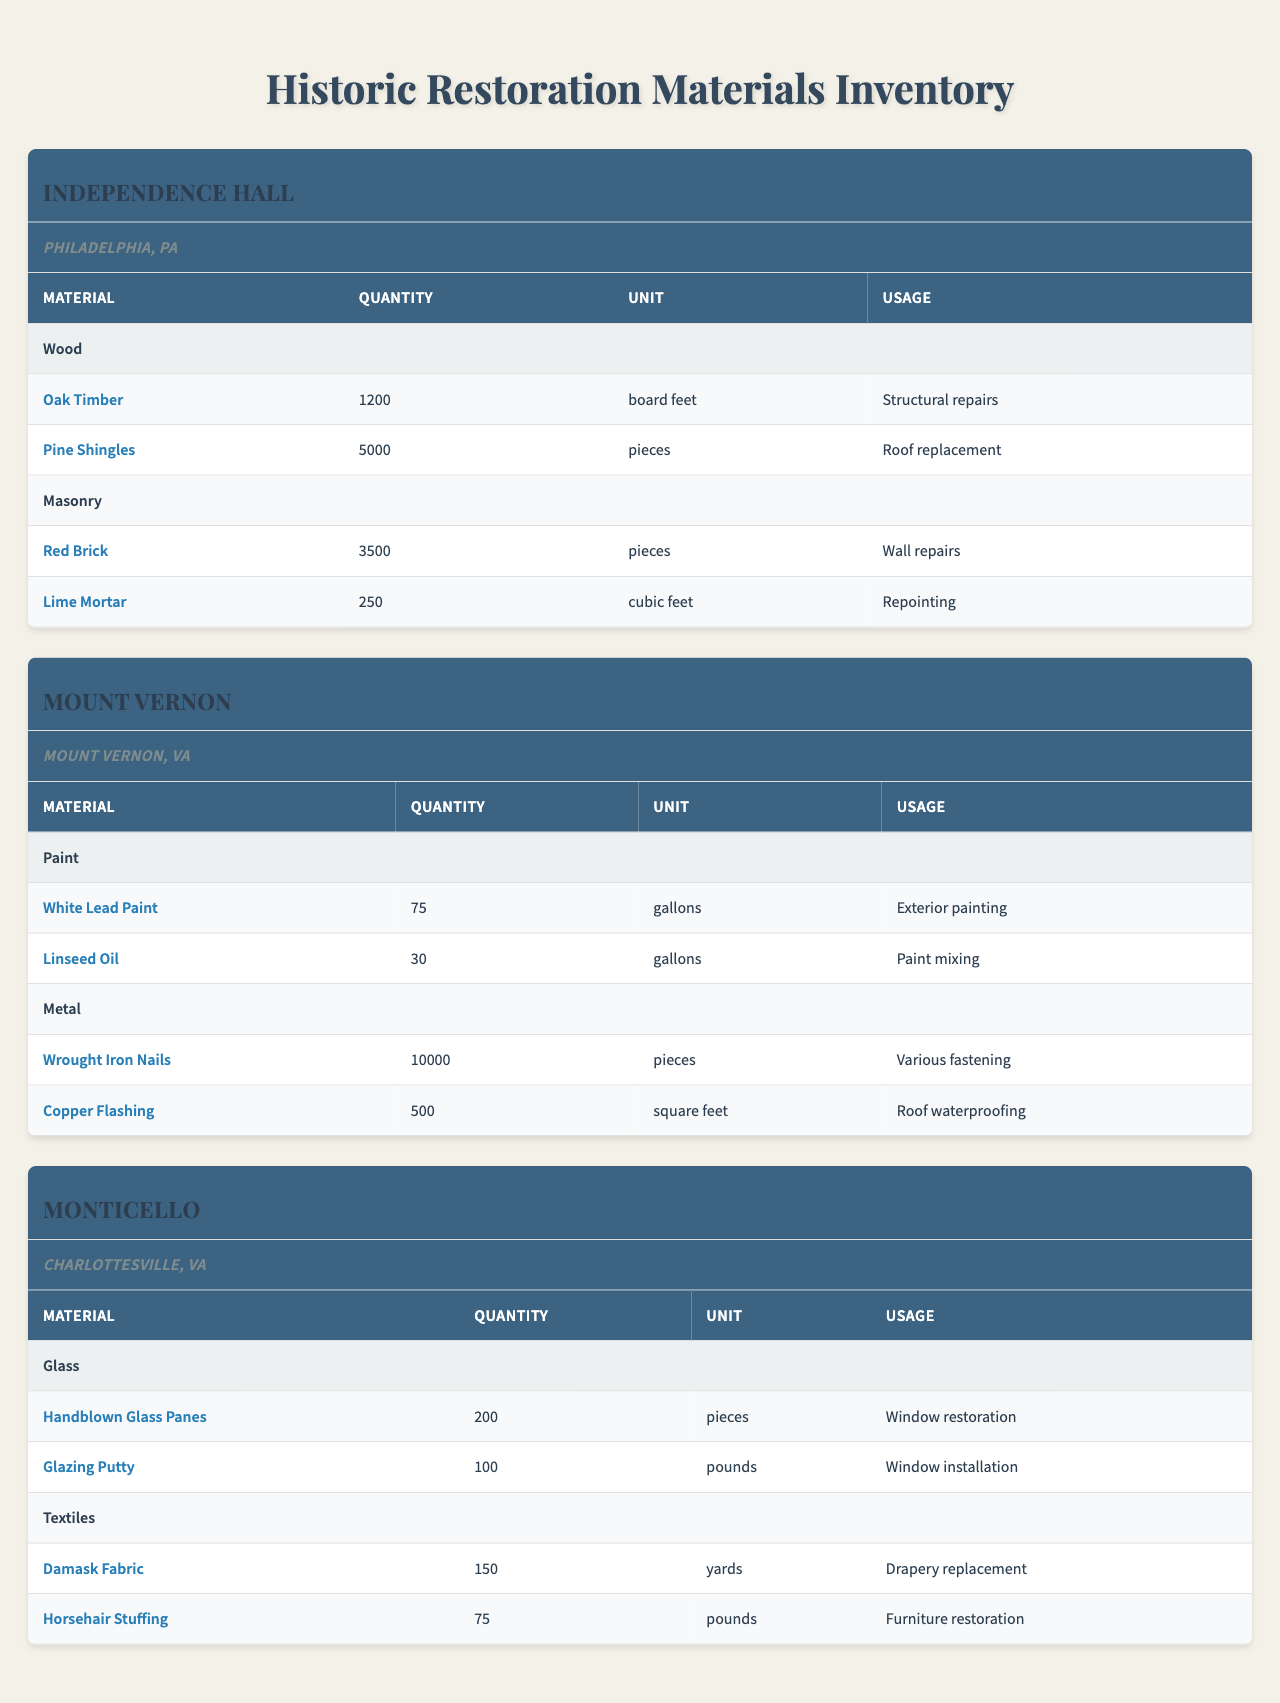What is the total quantity of Pine Shingles used at Independence Hall? The table shows that Pine Shingles have a quantity of 5000 pieces listed under Independence Hall's materials section. Therefore, the total quantity is simply the stated amount.
Answer: 5000 pieces Which site has the highest quantity of Wrought Iron Nails? According to the table, Mount Vernon has 10,000 Wrought Iron Nails listed, which is higher than any other site's materials. This makes it the site with the highest quantity for this item.
Answer: Mount Vernon What is the total quantity of masonry materials used at Independence Hall? For Independence Hall, the masonry materials listed are Red Brick (3500 pieces) and Lime Mortar (250 cubic feet). However, since these are in different units, we cannot technically sum them directly. Instead, we identify both quantities separately.
Answer: Red Brick: 3500 pieces, Lime Mortar: 250 cubic feet Is the quantity of Handblown Glass Panes at Monticello greater than the quantity of Oak Timber at Independence Hall? Monticello has 200 Handblown Glass Panes, while Independence Hall has 1200 Oak Timbers. Comparing these two quantities shows that 200 is less than 1200.
Answer: No What is the total quantity of all restoration materials used at Mount Vernon? The materials used at Mount Vernon are White Lead Paint (75 gallons), Linseed Oil (30 gallons), Wrought Iron Nails (10,000 pieces), and Copper Flashing (500 square feet). Summing these values: 75 + 30 + 10,000 + 500 = 10,605. This leads to the total quantity of all restoration materials at this site.
Answer: 10,605 How many total pounds of textiles do we have at Monticello? The textiles at Monticello include Damask Fabric (150 yards) and Horsehair Stuffing (75 pounds). Only the Horsehair Stuffing has the quantity in pounds, which can be directly stated.
Answer: 75 pounds Which site uses Lime Mortar, and how much is allocated for it? The table indicates that Lime Mortar is listed under the materials for Independence Hall, where it has a quantity of 250 cubic feet allocated for repointing.
Answer: Independence Hall, 250 cubic feet What is the total quantity of restoration items at Independence Hall compared to Monticello? At Independence Hall, the items include Oak Timber (1200 board feet), Pine Shingles (5000 pieces), Red Brick (3500 pieces), and Lime Mortar (250 cubic feet). This sums to 1200 + 5000 + 3500 + 250 = 10,950 for Independence Hall. At Monticello, Handblown Glass Panes (200 pieces) and Glazing Putty (100 pounds) contribute 200 + 100 = 300. Comparing both totals: 10,950 (Independence Hall) > 300 (Monticello).
Answer: Independence Hall has 10,950, Monticello has 300; Independence Hall has more What is the average quantity of Paint materials used across all sites? The paint materials listed include White Lead Paint (75 gallons) and Linseed Oil (30 gallons) at Mount Vernon. For the purpose of averaging, we’ll consider the total quantity: 75 + 30 = 105 gallons total, and there are 2 paint materials. Therefore, the average is 105 / 2 = 52.5.
Answer: 52.5 gallons Does Monticello use any materials for roofing? The table lists roofing materials only under Mount Vernon (Copper Flashing). Monticello has no roofing materials specified, indicating it does not use any materials for this purpose.
Answer: No 